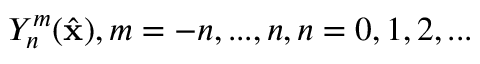<formula> <loc_0><loc_0><loc_500><loc_500>Y _ { n } ^ { m } ( \hat { x } ) , m = - n , \dots , n , n = 0 , 1 , 2 , \dots</formula> 